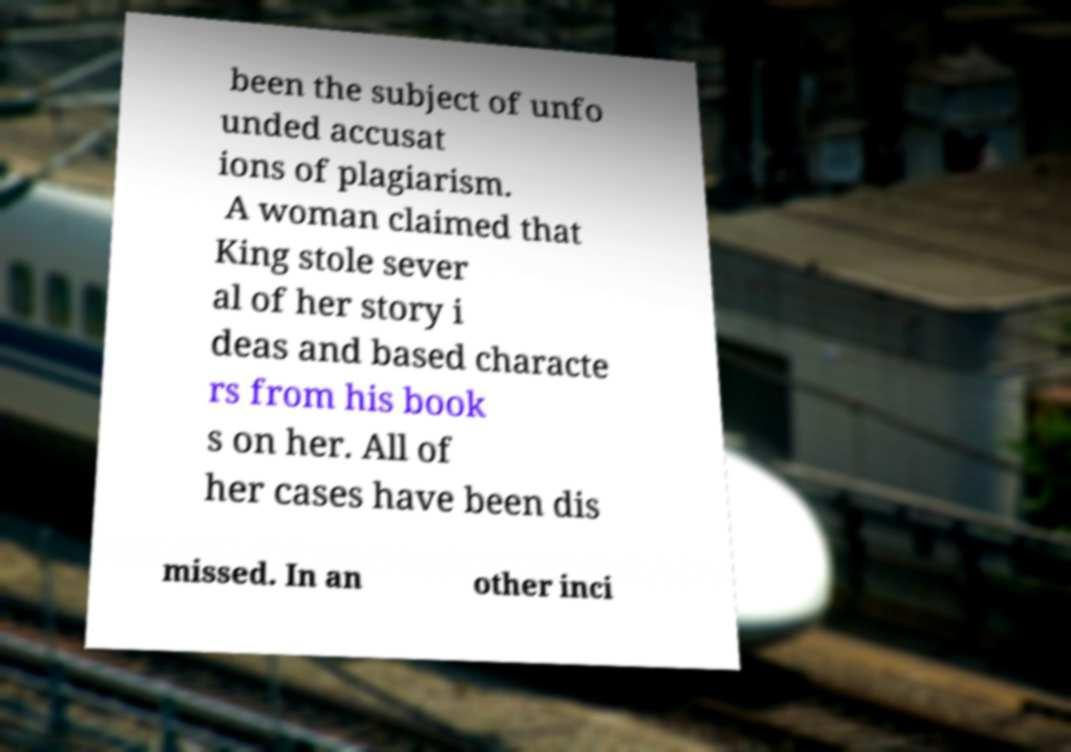For documentation purposes, I need the text within this image transcribed. Could you provide that? been the subject of unfo unded accusat ions of plagiarism. A woman claimed that King stole sever al of her story i deas and based characte rs from his book s on her. All of her cases have been dis missed. In an other inci 